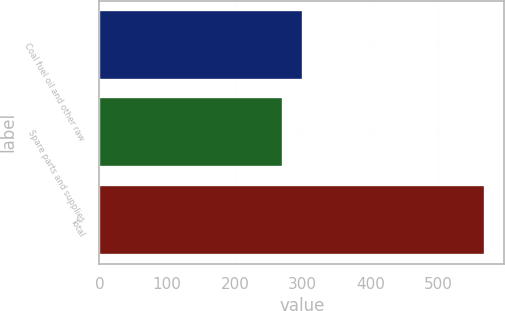Convert chart. <chart><loc_0><loc_0><loc_500><loc_500><bar_chart><fcel>Coal fuel oil and other raw<fcel>Spare parts and supplies<fcel>Total<nl><fcel>300.8<fcel>271<fcel>569<nl></chart> 